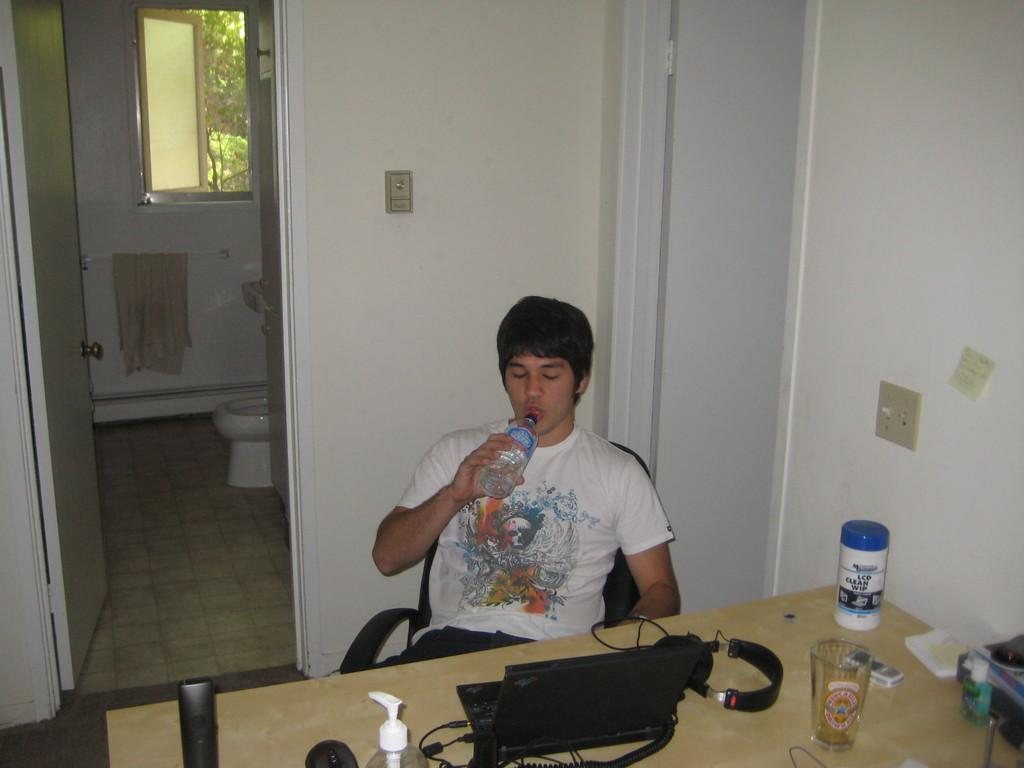Who is present in the image? There is a man in the image. What is the man doing in the image? The man is drinking in the image. What is the man's position in the image? The man is sitting in a chair in the image. What is on the table in front of the man? The man has a laptop and other accessories on the table in the image. How many doors are visible in the image? There are two doors on either side of the man in the image. What type of hat is the snake wearing in the image? There is no snake or hat present in the image. 